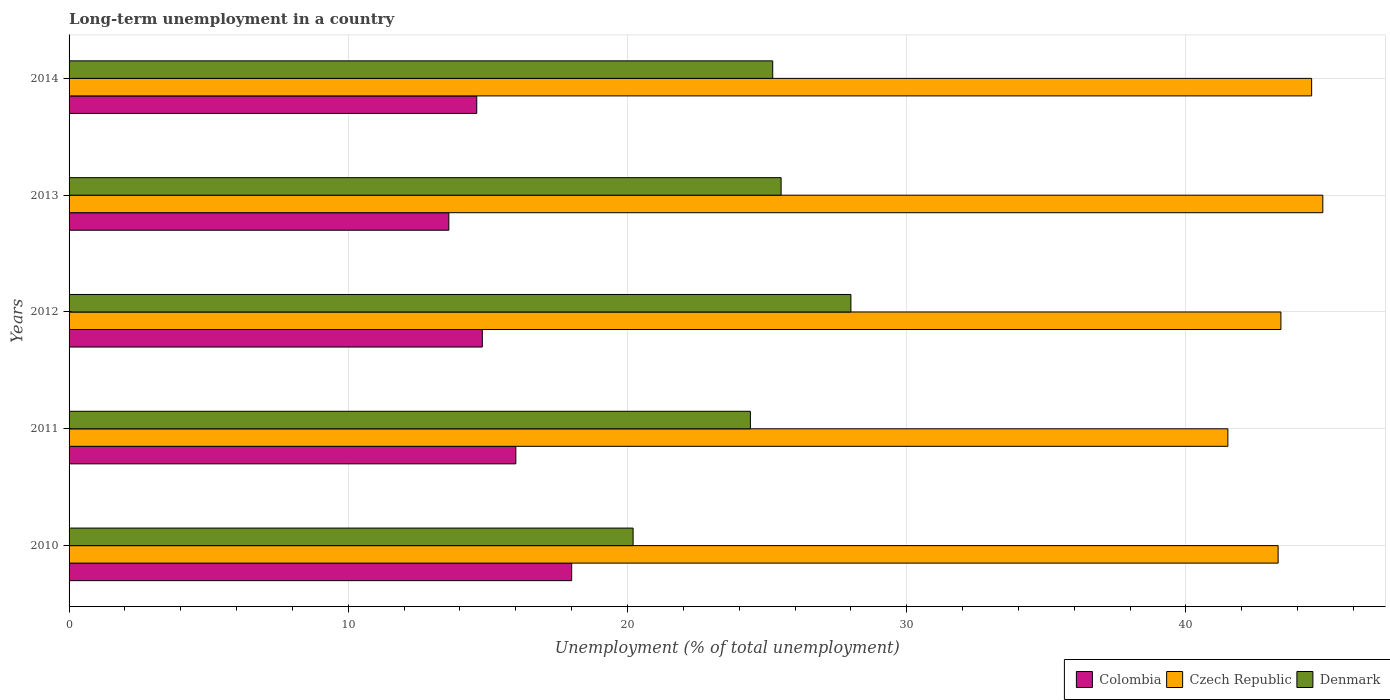How many groups of bars are there?
Provide a short and direct response. 5. Are the number of bars on each tick of the Y-axis equal?
Ensure brevity in your answer.  Yes. How many bars are there on the 2nd tick from the bottom?
Ensure brevity in your answer.  3. What is the label of the 1st group of bars from the top?
Make the answer very short. 2014. In how many cases, is the number of bars for a given year not equal to the number of legend labels?
Keep it short and to the point. 0. Across all years, what is the maximum percentage of long-term unemployed population in Denmark?
Your answer should be compact. 28. Across all years, what is the minimum percentage of long-term unemployed population in Denmark?
Your answer should be very brief. 20.2. In which year was the percentage of long-term unemployed population in Colombia maximum?
Ensure brevity in your answer.  2010. What is the total percentage of long-term unemployed population in Czech Republic in the graph?
Provide a succinct answer. 217.6. What is the difference between the percentage of long-term unemployed population in Denmark in 2010 and that in 2011?
Provide a short and direct response. -4.2. What is the difference between the percentage of long-term unemployed population in Czech Republic in 2010 and the percentage of long-term unemployed population in Colombia in 2011?
Make the answer very short. 27.3. What is the average percentage of long-term unemployed population in Colombia per year?
Give a very brief answer. 15.4. In the year 2014, what is the difference between the percentage of long-term unemployed population in Denmark and percentage of long-term unemployed population in Czech Republic?
Keep it short and to the point. -19.3. In how many years, is the percentage of long-term unemployed population in Denmark greater than 16 %?
Give a very brief answer. 5. What is the ratio of the percentage of long-term unemployed population in Colombia in 2012 to that in 2014?
Give a very brief answer. 1.01. Is the percentage of long-term unemployed population in Colombia in 2010 less than that in 2011?
Give a very brief answer. No. What is the difference between the highest and the second highest percentage of long-term unemployed population in Czech Republic?
Your answer should be very brief. 0.4. What is the difference between the highest and the lowest percentage of long-term unemployed population in Czech Republic?
Give a very brief answer. 3.4. What does the 3rd bar from the top in 2010 represents?
Provide a short and direct response. Colombia. What does the 1st bar from the bottom in 2014 represents?
Offer a terse response. Colombia. How many bars are there?
Your answer should be compact. 15. Are all the bars in the graph horizontal?
Keep it short and to the point. Yes. How many years are there in the graph?
Give a very brief answer. 5. What is the difference between two consecutive major ticks on the X-axis?
Ensure brevity in your answer.  10. Does the graph contain grids?
Give a very brief answer. Yes. How many legend labels are there?
Make the answer very short. 3. How are the legend labels stacked?
Provide a short and direct response. Horizontal. What is the title of the graph?
Make the answer very short. Long-term unemployment in a country. Does "Samoa" appear as one of the legend labels in the graph?
Your answer should be very brief. No. What is the label or title of the X-axis?
Keep it short and to the point. Unemployment (% of total unemployment). What is the Unemployment (% of total unemployment) in Czech Republic in 2010?
Keep it short and to the point. 43.3. What is the Unemployment (% of total unemployment) of Denmark in 2010?
Ensure brevity in your answer.  20.2. What is the Unemployment (% of total unemployment) of Czech Republic in 2011?
Offer a very short reply. 41.5. What is the Unemployment (% of total unemployment) in Denmark in 2011?
Offer a terse response. 24.4. What is the Unemployment (% of total unemployment) in Colombia in 2012?
Provide a succinct answer. 14.8. What is the Unemployment (% of total unemployment) in Czech Republic in 2012?
Offer a very short reply. 43.4. What is the Unemployment (% of total unemployment) of Denmark in 2012?
Ensure brevity in your answer.  28. What is the Unemployment (% of total unemployment) of Colombia in 2013?
Provide a succinct answer. 13.6. What is the Unemployment (% of total unemployment) in Czech Republic in 2013?
Keep it short and to the point. 44.9. What is the Unemployment (% of total unemployment) in Colombia in 2014?
Your answer should be very brief. 14.6. What is the Unemployment (% of total unemployment) in Czech Republic in 2014?
Give a very brief answer. 44.5. What is the Unemployment (% of total unemployment) in Denmark in 2014?
Your response must be concise. 25.2. Across all years, what is the maximum Unemployment (% of total unemployment) in Colombia?
Ensure brevity in your answer.  18. Across all years, what is the maximum Unemployment (% of total unemployment) of Czech Republic?
Give a very brief answer. 44.9. Across all years, what is the minimum Unemployment (% of total unemployment) of Colombia?
Give a very brief answer. 13.6. Across all years, what is the minimum Unemployment (% of total unemployment) in Czech Republic?
Keep it short and to the point. 41.5. Across all years, what is the minimum Unemployment (% of total unemployment) in Denmark?
Your answer should be very brief. 20.2. What is the total Unemployment (% of total unemployment) of Colombia in the graph?
Give a very brief answer. 77. What is the total Unemployment (% of total unemployment) of Czech Republic in the graph?
Give a very brief answer. 217.6. What is the total Unemployment (% of total unemployment) in Denmark in the graph?
Make the answer very short. 123.3. What is the difference between the Unemployment (% of total unemployment) in Colombia in 2010 and that in 2011?
Offer a very short reply. 2. What is the difference between the Unemployment (% of total unemployment) of Czech Republic in 2010 and that in 2011?
Your answer should be very brief. 1.8. What is the difference between the Unemployment (% of total unemployment) in Denmark in 2010 and that in 2011?
Offer a very short reply. -4.2. What is the difference between the Unemployment (% of total unemployment) of Czech Republic in 2010 and that in 2012?
Make the answer very short. -0.1. What is the difference between the Unemployment (% of total unemployment) in Denmark in 2010 and that in 2012?
Ensure brevity in your answer.  -7.8. What is the difference between the Unemployment (% of total unemployment) in Czech Republic in 2010 and that in 2013?
Provide a succinct answer. -1.6. What is the difference between the Unemployment (% of total unemployment) of Denmark in 2010 and that in 2013?
Your answer should be compact. -5.3. What is the difference between the Unemployment (% of total unemployment) in Colombia in 2010 and that in 2014?
Give a very brief answer. 3.4. What is the difference between the Unemployment (% of total unemployment) in Czech Republic in 2010 and that in 2014?
Offer a terse response. -1.2. What is the difference between the Unemployment (% of total unemployment) in Czech Republic in 2011 and that in 2012?
Keep it short and to the point. -1.9. What is the difference between the Unemployment (% of total unemployment) of Czech Republic in 2011 and that in 2013?
Make the answer very short. -3.4. What is the difference between the Unemployment (% of total unemployment) in Denmark in 2011 and that in 2013?
Offer a very short reply. -1.1. What is the difference between the Unemployment (% of total unemployment) of Denmark in 2011 and that in 2014?
Ensure brevity in your answer.  -0.8. What is the difference between the Unemployment (% of total unemployment) in Denmark in 2012 and that in 2013?
Make the answer very short. 2.5. What is the difference between the Unemployment (% of total unemployment) of Colombia in 2010 and the Unemployment (% of total unemployment) of Czech Republic in 2011?
Offer a terse response. -23.5. What is the difference between the Unemployment (% of total unemployment) of Colombia in 2010 and the Unemployment (% of total unemployment) of Denmark in 2011?
Keep it short and to the point. -6.4. What is the difference between the Unemployment (% of total unemployment) of Colombia in 2010 and the Unemployment (% of total unemployment) of Czech Republic in 2012?
Offer a very short reply. -25.4. What is the difference between the Unemployment (% of total unemployment) in Colombia in 2010 and the Unemployment (% of total unemployment) in Denmark in 2012?
Keep it short and to the point. -10. What is the difference between the Unemployment (% of total unemployment) of Colombia in 2010 and the Unemployment (% of total unemployment) of Czech Republic in 2013?
Offer a terse response. -26.9. What is the difference between the Unemployment (% of total unemployment) in Colombia in 2010 and the Unemployment (% of total unemployment) in Czech Republic in 2014?
Keep it short and to the point. -26.5. What is the difference between the Unemployment (% of total unemployment) in Colombia in 2010 and the Unemployment (% of total unemployment) in Denmark in 2014?
Offer a very short reply. -7.2. What is the difference between the Unemployment (% of total unemployment) of Czech Republic in 2010 and the Unemployment (% of total unemployment) of Denmark in 2014?
Make the answer very short. 18.1. What is the difference between the Unemployment (% of total unemployment) of Colombia in 2011 and the Unemployment (% of total unemployment) of Czech Republic in 2012?
Offer a very short reply. -27.4. What is the difference between the Unemployment (% of total unemployment) of Colombia in 2011 and the Unemployment (% of total unemployment) of Denmark in 2012?
Your answer should be compact. -12. What is the difference between the Unemployment (% of total unemployment) in Colombia in 2011 and the Unemployment (% of total unemployment) in Czech Republic in 2013?
Keep it short and to the point. -28.9. What is the difference between the Unemployment (% of total unemployment) of Colombia in 2011 and the Unemployment (% of total unemployment) of Denmark in 2013?
Offer a very short reply. -9.5. What is the difference between the Unemployment (% of total unemployment) in Czech Republic in 2011 and the Unemployment (% of total unemployment) in Denmark in 2013?
Ensure brevity in your answer.  16. What is the difference between the Unemployment (% of total unemployment) of Colombia in 2011 and the Unemployment (% of total unemployment) of Czech Republic in 2014?
Offer a terse response. -28.5. What is the difference between the Unemployment (% of total unemployment) of Czech Republic in 2011 and the Unemployment (% of total unemployment) of Denmark in 2014?
Your answer should be compact. 16.3. What is the difference between the Unemployment (% of total unemployment) of Colombia in 2012 and the Unemployment (% of total unemployment) of Czech Republic in 2013?
Make the answer very short. -30.1. What is the difference between the Unemployment (% of total unemployment) in Colombia in 2012 and the Unemployment (% of total unemployment) in Denmark in 2013?
Your answer should be very brief. -10.7. What is the difference between the Unemployment (% of total unemployment) of Colombia in 2012 and the Unemployment (% of total unemployment) of Czech Republic in 2014?
Offer a very short reply. -29.7. What is the difference between the Unemployment (% of total unemployment) in Colombia in 2012 and the Unemployment (% of total unemployment) in Denmark in 2014?
Keep it short and to the point. -10.4. What is the difference between the Unemployment (% of total unemployment) in Czech Republic in 2012 and the Unemployment (% of total unemployment) in Denmark in 2014?
Provide a succinct answer. 18.2. What is the difference between the Unemployment (% of total unemployment) in Colombia in 2013 and the Unemployment (% of total unemployment) in Czech Republic in 2014?
Keep it short and to the point. -30.9. What is the difference between the Unemployment (% of total unemployment) in Czech Republic in 2013 and the Unemployment (% of total unemployment) in Denmark in 2014?
Offer a very short reply. 19.7. What is the average Unemployment (% of total unemployment) of Czech Republic per year?
Offer a very short reply. 43.52. What is the average Unemployment (% of total unemployment) in Denmark per year?
Make the answer very short. 24.66. In the year 2010, what is the difference between the Unemployment (% of total unemployment) of Colombia and Unemployment (% of total unemployment) of Czech Republic?
Your response must be concise. -25.3. In the year 2010, what is the difference between the Unemployment (% of total unemployment) in Czech Republic and Unemployment (% of total unemployment) in Denmark?
Your answer should be very brief. 23.1. In the year 2011, what is the difference between the Unemployment (% of total unemployment) in Colombia and Unemployment (% of total unemployment) in Czech Republic?
Your answer should be very brief. -25.5. In the year 2011, what is the difference between the Unemployment (% of total unemployment) of Colombia and Unemployment (% of total unemployment) of Denmark?
Offer a very short reply. -8.4. In the year 2012, what is the difference between the Unemployment (% of total unemployment) of Colombia and Unemployment (% of total unemployment) of Czech Republic?
Your answer should be compact. -28.6. In the year 2012, what is the difference between the Unemployment (% of total unemployment) in Colombia and Unemployment (% of total unemployment) in Denmark?
Your response must be concise. -13.2. In the year 2013, what is the difference between the Unemployment (% of total unemployment) in Colombia and Unemployment (% of total unemployment) in Czech Republic?
Your answer should be very brief. -31.3. In the year 2013, what is the difference between the Unemployment (% of total unemployment) in Colombia and Unemployment (% of total unemployment) in Denmark?
Provide a succinct answer. -11.9. In the year 2013, what is the difference between the Unemployment (% of total unemployment) in Czech Republic and Unemployment (% of total unemployment) in Denmark?
Your response must be concise. 19.4. In the year 2014, what is the difference between the Unemployment (% of total unemployment) of Colombia and Unemployment (% of total unemployment) of Czech Republic?
Offer a terse response. -29.9. In the year 2014, what is the difference between the Unemployment (% of total unemployment) in Czech Republic and Unemployment (% of total unemployment) in Denmark?
Offer a terse response. 19.3. What is the ratio of the Unemployment (% of total unemployment) of Colombia in 2010 to that in 2011?
Ensure brevity in your answer.  1.12. What is the ratio of the Unemployment (% of total unemployment) in Czech Republic in 2010 to that in 2011?
Your answer should be very brief. 1.04. What is the ratio of the Unemployment (% of total unemployment) in Denmark in 2010 to that in 2011?
Give a very brief answer. 0.83. What is the ratio of the Unemployment (% of total unemployment) of Colombia in 2010 to that in 2012?
Your answer should be very brief. 1.22. What is the ratio of the Unemployment (% of total unemployment) in Czech Republic in 2010 to that in 2012?
Offer a terse response. 1. What is the ratio of the Unemployment (% of total unemployment) of Denmark in 2010 to that in 2012?
Give a very brief answer. 0.72. What is the ratio of the Unemployment (% of total unemployment) in Colombia in 2010 to that in 2013?
Make the answer very short. 1.32. What is the ratio of the Unemployment (% of total unemployment) of Czech Republic in 2010 to that in 2013?
Your response must be concise. 0.96. What is the ratio of the Unemployment (% of total unemployment) of Denmark in 2010 to that in 2013?
Make the answer very short. 0.79. What is the ratio of the Unemployment (% of total unemployment) in Colombia in 2010 to that in 2014?
Offer a terse response. 1.23. What is the ratio of the Unemployment (% of total unemployment) in Denmark in 2010 to that in 2014?
Offer a terse response. 0.8. What is the ratio of the Unemployment (% of total unemployment) of Colombia in 2011 to that in 2012?
Your answer should be very brief. 1.08. What is the ratio of the Unemployment (% of total unemployment) in Czech Republic in 2011 to that in 2012?
Your response must be concise. 0.96. What is the ratio of the Unemployment (% of total unemployment) of Denmark in 2011 to that in 2012?
Ensure brevity in your answer.  0.87. What is the ratio of the Unemployment (% of total unemployment) in Colombia in 2011 to that in 2013?
Your answer should be very brief. 1.18. What is the ratio of the Unemployment (% of total unemployment) in Czech Republic in 2011 to that in 2013?
Offer a terse response. 0.92. What is the ratio of the Unemployment (% of total unemployment) of Denmark in 2011 to that in 2013?
Ensure brevity in your answer.  0.96. What is the ratio of the Unemployment (% of total unemployment) in Colombia in 2011 to that in 2014?
Your response must be concise. 1.1. What is the ratio of the Unemployment (% of total unemployment) in Czech Republic in 2011 to that in 2014?
Offer a terse response. 0.93. What is the ratio of the Unemployment (% of total unemployment) in Denmark in 2011 to that in 2014?
Give a very brief answer. 0.97. What is the ratio of the Unemployment (% of total unemployment) of Colombia in 2012 to that in 2013?
Provide a succinct answer. 1.09. What is the ratio of the Unemployment (% of total unemployment) of Czech Republic in 2012 to that in 2013?
Your answer should be very brief. 0.97. What is the ratio of the Unemployment (% of total unemployment) in Denmark in 2012 to that in 2013?
Provide a succinct answer. 1.1. What is the ratio of the Unemployment (% of total unemployment) in Colombia in 2012 to that in 2014?
Ensure brevity in your answer.  1.01. What is the ratio of the Unemployment (% of total unemployment) of Czech Republic in 2012 to that in 2014?
Make the answer very short. 0.98. What is the ratio of the Unemployment (% of total unemployment) in Colombia in 2013 to that in 2014?
Ensure brevity in your answer.  0.93. What is the ratio of the Unemployment (% of total unemployment) in Czech Republic in 2013 to that in 2014?
Your answer should be compact. 1.01. What is the ratio of the Unemployment (% of total unemployment) in Denmark in 2013 to that in 2014?
Ensure brevity in your answer.  1.01. What is the difference between the highest and the second highest Unemployment (% of total unemployment) in Czech Republic?
Your answer should be compact. 0.4. What is the difference between the highest and the lowest Unemployment (% of total unemployment) in Czech Republic?
Give a very brief answer. 3.4. What is the difference between the highest and the lowest Unemployment (% of total unemployment) of Denmark?
Your response must be concise. 7.8. 